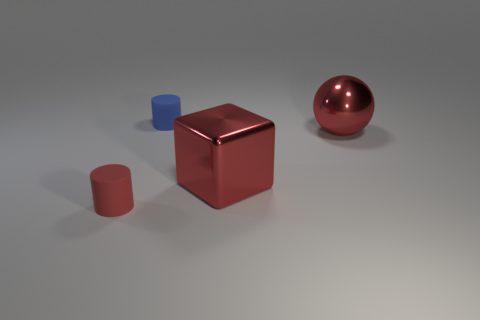What shape is the small blue matte object?
Ensure brevity in your answer.  Cylinder. There is a rubber cylinder to the right of the small red matte object; is there a tiny blue thing to the left of it?
Offer a very short reply. No. There is a object that is the same size as the red cylinder; what material is it?
Make the answer very short. Rubber. Are there any red objects that have the same size as the ball?
Ensure brevity in your answer.  Yes. What material is the cube on the right side of the blue matte object?
Your answer should be very brief. Metal. Is the material of the cylinder on the right side of the tiny red rubber object the same as the big red ball?
Offer a very short reply. No. There is a red metallic thing that is the same size as the red metal sphere; what is its shape?
Keep it short and to the point. Cube. How many cylinders have the same color as the block?
Your answer should be compact. 1. Are there fewer things in front of the blue cylinder than large red objects that are to the right of the big red metal sphere?
Give a very brief answer. No. There is a small red object; are there any small rubber cylinders behind it?
Give a very brief answer. Yes. 